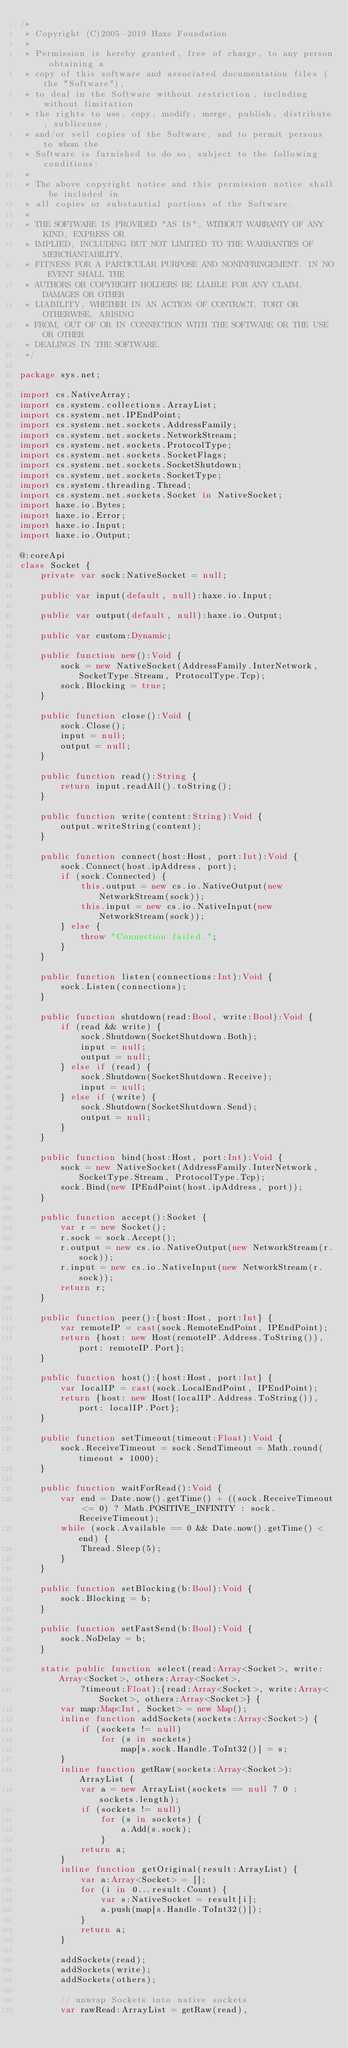<code> <loc_0><loc_0><loc_500><loc_500><_Haxe_>/*
 * Copyright (C)2005-2019 Haxe Foundation
 *
 * Permission is hereby granted, free of charge, to any person obtaining a
 * copy of this software and associated documentation files (the "Software"),
 * to deal in the Software without restriction, including without limitation
 * the rights to use, copy, modify, merge, publish, distribute, sublicense,
 * and/or sell copies of the Software, and to permit persons to whom the
 * Software is furnished to do so, subject to the following conditions:
 *
 * The above copyright notice and this permission notice shall be included in
 * all copies or substantial portions of the Software.
 *
 * THE SOFTWARE IS PROVIDED "AS IS", WITHOUT WARRANTY OF ANY KIND, EXPRESS OR
 * IMPLIED, INCLUDING BUT NOT LIMITED TO THE WARRANTIES OF MERCHANTABILITY,
 * FITNESS FOR A PARTICULAR PURPOSE AND NONINFRINGEMENT. IN NO EVENT SHALL THE
 * AUTHORS OR COPYRIGHT HOLDERS BE LIABLE FOR ANY CLAIM, DAMAGES OR OTHER
 * LIABILITY, WHETHER IN AN ACTION OF CONTRACT, TORT OR OTHERWISE, ARISING
 * FROM, OUT OF OR IN CONNECTION WITH THE SOFTWARE OR THE USE OR OTHER
 * DEALINGS IN THE SOFTWARE.
 */

package sys.net;

import cs.NativeArray;
import cs.system.collections.ArrayList;
import cs.system.net.IPEndPoint;
import cs.system.net.sockets.AddressFamily;
import cs.system.net.sockets.NetworkStream;
import cs.system.net.sockets.ProtocolType;
import cs.system.net.sockets.SocketFlags;
import cs.system.net.sockets.SocketShutdown;
import cs.system.net.sockets.SocketType;
import cs.system.threading.Thread;
import cs.system.net.sockets.Socket in NativeSocket;
import haxe.io.Bytes;
import haxe.io.Error;
import haxe.io.Input;
import haxe.io.Output;

@:coreApi
class Socket {
	private var sock:NativeSocket = null;

	public var input(default, null):haxe.io.Input;

	public var output(default, null):haxe.io.Output;

	public var custom:Dynamic;

	public function new():Void {
		sock = new NativeSocket(AddressFamily.InterNetwork, SocketType.Stream, ProtocolType.Tcp);
		sock.Blocking = true;
	}

	public function close():Void {
		sock.Close();
		input = null;
		output = null;
	}

	public function read():String {
		return input.readAll().toString();
	}

	public function write(content:String):Void {
		output.writeString(content);
	}

	public function connect(host:Host, port:Int):Void {
		sock.Connect(host.ipAddress, port);
		if (sock.Connected) {
			this.output = new cs.io.NativeOutput(new NetworkStream(sock));
			this.input = new cs.io.NativeInput(new NetworkStream(sock));
		} else {
			throw "Connection failed.";
		}
	}

	public function listen(connections:Int):Void {
		sock.Listen(connections);
	}

	public function shutdown(read:Bool, write:Bool):Void {
		if (read && write) {
			sock.Shutdown(SocketShutdown.Both);
			input = null;
			output = null;
		} else if (read) {
			sock.Shutdown(SocketShutdown.Receive);
			input = null;
		} else if (write) {
			sock.Shutdown(SocketShutdown.Send);
			output = null;
		}
	}

	public function bind(host:Host, port:Int):Void {
		sock = new NativeSocket(AddressFamily.InterNetwork, SocketType.Stream, ProtocolType.Tcp);
		sock.Bind(new IPEndPoint(host.ipAddress, port));
	}

	public function accept():Socket {
		var r = new Socket();
		r.sock = sock.Accept();
		r.output = new cs.io.NativeOutput(new NetworkStream(r.sock));
		r.input = new cs.io.NativeInput(new NetworkStream(r.sock));
		return r;
	}

	public function peer():{host:Host, port:Int} {
		var remoteIP = cast(sock.RemoteEndPoint, IPEndPoint);
		return {host: new Host(remoteIP.Address.ToString()), port: remoteIP.Port};
	}

	public function host():{host:Host, port:Int} {
		var localIP = cast(sock.LocalEndPoint, IPEndPoint);
		return {host: new Host(localIP.Address.ToString()), port: localIP.Port};
	}

	public function setTimeout(timeout:Float):Void {
		sock.ReceiveTimeout = sock.SendTimeout = Math.round(timeout * 1000);
	}

	public function waitForRead():Void {
		var end = Date.now().getTime() + ((sock.ReceiveTimeout <= 0) ? Math.POSITIVE_INFINITY : sock.ReceiveTimeout);
		while (sock.Available == 0 && Date.now().getTime() < end) {
			Thread.Sleep(5);
		}
	}

	public function setBlocking(b:Bool):Void {
		sock.Blocking = b;
	}

	public function setFastSend(b:Bool):Void {
		sock.NoDelay = b;
	}

	static public function select(read:Array<Socket>, write:Array<Socket>, others:Array<Socket>,
			?timeout:Float):{read:Array<Socket>, write:Array<Socket>, others:Array<Socket>} {
		var map:Map<Int, Socket> = new Map();
		inline function addSockets(sockets:Array<Socket>) {
			if (sockets != null)
				for (s in sockets)
					map[s.sock.Handle.ToInt32()] = s;
		}
		inline function getRaw(sockets:Array<Socket>):ArrayList {
			var a = new ArrayList(sockets == null ? 0 : sockets.length);
			if (sockets != null)
				for (s in sockets) {
					a.Add(s.sock);
				}
			return a;
		}
		inline function getOriginal(result:ArrayList) {
			var a:Array<Socket> = [];
			for (i in 0...result.Count) {
				var s:NativeSocket = result[i];
				a.push(map[s.Handle.ToInt32()]);
			}
			return a;
		}

		addSockets(read);
		addSockets(write);
		addSockets(others);

		// unwrap Sockets into native sockets
		var rawRead:ArrayList = getRaw(read),</code> 